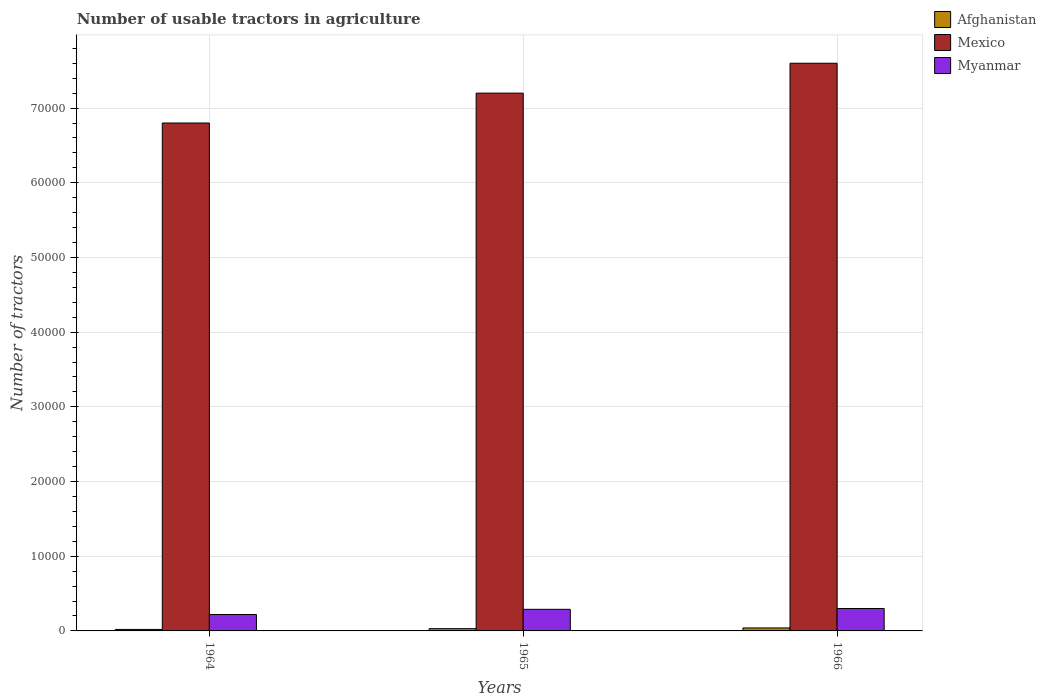How many different coloured bars are there?
Give a very brief answer. 3. How many groups of bars are there?
Your answer should be compact. 3. Are the number of bars per tick equal to the number of legend labels?
Keep it short and to the point. Yes. How many bars are there on the 2nd tick from the right?
Provide a succinct answer. 3. What is the label of the 1st group of bars from the left?
Provide a short and direct response. 1964. In how many cases, is the number of bars for a given year not equal to the number of legend labels?
Make the answer very short. 0. What is the number of usable tractors in agriculture in Myanmar in 1965?
Offer a very short reply. 2891. Across all years, what is the maximum number of usable tractors in agriculture in Afghanistan?
Give a very brief answer. 400. Across all years, what is the minimum number of usable tractors in agriculture in Mexico?
Ensure brevity in your answer.  6.80e+04. In which year was the number of usable tractors in agriculture in Myanmar maximum?
Your answer should be very brief. 1966. In which year was the number of usable tractors in agriculture in Afghanistan minimum?
Offer a very short reply. 1964. What is the total number of usable tractors in agriculture in Mexico in the graph?
Provide a succinct answer. 2.16e+05. What is the difference between the number of usable tractors in agriculture in Afghanistan in 1964 and that in 1966?
Provide a succinct answer. -200. What is the difference between the number of usable tractors in agriculture in Myanmar in 1966 and the number of usable tractors in agriculture in Afghanistan in 1964?
Provide a succinct answer. 2800. What is the average number of usable tractors in agriculture in Mexico per year?
Your response must be concise. 7.20e+04. In the year 1965, what is the difference between the number of usable tractors in agriculture in Myanmar and number of usable tractors in agriculture in Afghanistan?
Your answer should be very brief. 2591. In how many years, is the number of usable tractors in agriculture in Mexico greater than 70000?
Ensure brevity in your answer.  2. What is the ratio of the number of usable tractors in agriculture in Myanmar in 1964 to that in 1965?
Ensure brevity in your answer.  0.76. What is the difference between the highest and the lowest number of usable tractors in agriculture in Mexico?
Offer a very short reply. 8000. What does the 3rd bar from the left in 1965 represents?
Your response must be concise. Myanmar. What does the 1st bar from the right in 1966 represents?
Make the answer very short. Myanmar. Is it the case that in every year, the sum of the number of usable tractors in agriculture in Afghanistan and number of usable tractors in agriculture in Myanmar is greater than the number of usable tractors in agriculture in Mexico?
Provide a short and direct response. No. Are the values on the major ticks of Y-axis written in scientific E-notation?
Ensure brevity in your answer.  No. Does the graph contain any zero values?
Ensure brevity in your answer.  No. Does the graph contain grids?
Keep it short and to the point. Yes. How many legend labels are there?
Provide a succinct answer. 3. How are the legend labels stacked?
Make the answer very short. Vertical. What is the title of the graph?
Provide a short and direct response. Number of usable tractors in agriculture. Does "Congo (Democratic)" appear as one of the legend labels in the graph?
Provide a succinct answer. No. What is the label or title of the X-axis?
Give a very brief answer. Years. What is the label or title of the Y-axis?
Provide a succinct answer. Number of tractors. What is the Number of tractors in Mexico in 1964?
Offer a terse response. 6.80e+04. What is the Number of tractors in Myanmar in 1964?
Offer a terse response. 2200. What is the Number of tractors of Afghanistan in 1965?
Keep it short and to the point. 300. What is the Number of tractors of Mexico in 1965?
Offer a terse response. 7.20e+04. What is the Number of tractors in Myanmar in 1965?
Offer a very short reply. 2891. What is the Number of tractors in Afghanistan in 1966?
Your response must be concise. 400. What is the Number of tractors of Mexico in 1966?
Offer a terse response. 7.60e+04. What is the Number of tractors in Myanmar in 1966?
Ensure brevity in your answer.  3000. Across all years, what is the maximum Number of tractors of Afghanistan?
Give a very brief answer. 400. Across all years, what is the maximum Number of tractors of Mexico?
Provide a short and direct response. 7.60e+04. Across all years, what is the maximum Number of tractors in Myanmar?
Offer a terse response. 3000. Across all years, what is the minimum Number of tractors of Afghanistan?
Your answer should be very brief. 200. Across all years, what is the minimum Number of tractors of Mexico?
Your answer should be very brief. 6.80e+04. Across all years, what is the minimum Number of tractors in Myanmar?
Give a very brief answer. 2200. What is the total Number of tractors of Afghanistan in the graph?
Make the answer very short. 900. What is the total Number of tractors in Mexico in the graph?
Provide a succinct answer. 2.16e+05. What is the total Number of tractors in Myanmar in the graph?
Give a very brief answer. 8091. What is the difference between the Number of tractors in Afghanistan in 1964 and that in 1965?
Give a very brief answer. -100. What is the difference between the Number of tractors in Mexico in 1964 and that in 1965?
Offer a terse response. -4000. What is the difference between the Number of tractors in Myanmar in 1964 and that in 1965?
Provide a short and direct response. -691. What is the difference between the Number of tractors of Afghanistan in 1964 and that in 1966?
Offer a very short reply. -200. What is the difference between the Number of tractors in Mexico in 1964 and that in 1966?
Make the answer very short. -8000. What is the difference between the Number of tractors of Myanmar in 1964 and that in 1966?
Ensure brevity in your answer.  -800. What is the difference between the Number of tractors in Afghanistan in 1965 and that in 1966?
Keep it short and to the point. -100. What is the difference between the Number of tractors of Mexico in 1965 and that in 1966?
Keep it short and to the point. -4000. What is the difference between the Number of tractors of Myanmar in 1965 and that in 1966?
Offer a very short reply. -109. What is the difference between the Number of tractors in Afghanistan in 1964 and the Number of tractors in Mexico in 1965?
Ensure brevity in your answer.  -7.18e+04. What is the difference between the Number of tractors of Afghanistan in 1964 and the Number of tractors of Myanmar in 1965?
Offer a terse response. -2691. What is the difference between the Number of tractors of Mexico in 1964 and the Number of tractors of Myanmar in 1965?
Provide a short and direct response. 6.51e+04. What is the difference between the Number of tractors in Afghanistan in 1964 and the Number of tractors in Mexico in 1966?
Your answer should be very brief. -7.58e+04. What is the difference between the Number of tractors of Afghanistan in 1964 and the Number of tractors of Myanmar in 1966?
Your response must be concise. -2800. What is the difference between the Number of tractors in Mexico in 1964 and the Number of tractors in Myanmar in 1966?
Your answer should be compact. 6.50e+04. What is the difference between the Number of tractors of Afghanistan in 1965 and the Number of tractors of Mexico in 1966?
Your response must be concise. -7.57e+04. What is the difference between the Number of tractors in Afghanistan in 1965 and the Number of tractors in Myanmar in 1966?
Offer a very short reply. -2700. What is the difference between the Number of tractors of Mexico in 1965 and the Number of tractors of Myanmar in 1966?
Provide a succinct answer. 6.90e+04. What is the average Number of tractors of Afghanistan per year?
Make the answer very short. 300. What is the average Number of tractors of Mexico per year?
Give a very brief answer. 7.20e+04. What is the average Number of tractors in Myanmar per year?
Offer a terse response. 2697. In the year 1964, what is the difference between the Number of tractors in Afghanistan and Number of tractors in Mexico?
Provide a short and direct response. -6.78e+04. In the year 1964, what is the difference between the Number of tractors of Afghanistan and Number of tractors of Myanmar?
Make the answer very short. -2000. In the year 1964, what is the difference between the Number of tractors of Mexico and Number of tractors of Myanmar?
Offer a terse response. 6.58e+04. In the year 1965, what is the difference between the Number of tractors of Afghanistan and Number of tractors of Mexico?
Offer a terse response. -7.17e+04. In the year 1965, what is the difference between the Number of tractors of Afghanistan and Number of tractors of Myanmar?
Provide a succinct answer. -2591. In the year 1965, what is the difference between the Number of tractors of Mexico and Number of tractors of Myanmar?
Make the answer very short. 6.91e+04. In the year 1966, what is the difference between the Number of tractors of Afghanistan and Number of tractors of Mexico?
Offer a very short reply. -7.56e+04. In the year 1966, what is the difference between the Number of tractors in Afghanistan and Number of tractors in Myanmar?
Provide a short and direct response. -2600. In the year 1966, what is the difference between the Number of tractors in Mexico and Number of tractors in Myanmar?
Your answer should be compact. 7.30e+04. What is the ratio of the Number of tractors of Mexico in 1964 to that in 1965?
Ensure brevity in your answer.  0.94. What is the ratio of the Number of tractors in Myanmar in 1964 to that in 1965?
Your answer should be compact. 0.76. What is the ratio of the Number of tractors of Afghanistan in 1964 to that in 1966?
Keep it short and to the point. 0.5. What is the ratio of the Number of tractors of Mexico in 1964 to that in 1966?
Keep it short and to the point. 0.89. What is the ratio of the Number of tractors of Myanmar in 1964 to that in 1966?
Ensure brevity in your answer.  0.73. What is the ratio of the Number of tractors of Myanmar in 1965 to that in 1966?
Ensure brevity in your answer.  0.96. What is the difference between the highest and the second highest Number of tractors in Afghanistan?
Give a very brief answer. 100. What is the difference between the highest and the second highest Number of tractors of Mexico?
Your response must be concise. 4000. What is the difference between the highest and the second highest Number of tractors of Myanmar?
Offer a very short reply. 109. What is the difference between the highest and the lowest Number of tractors of Mexico?
Provide a succinct answer. 8000. What is the difference between the highest and the lowest Number of tractors of Myanmar?
Provide a succinct answer. 800. 